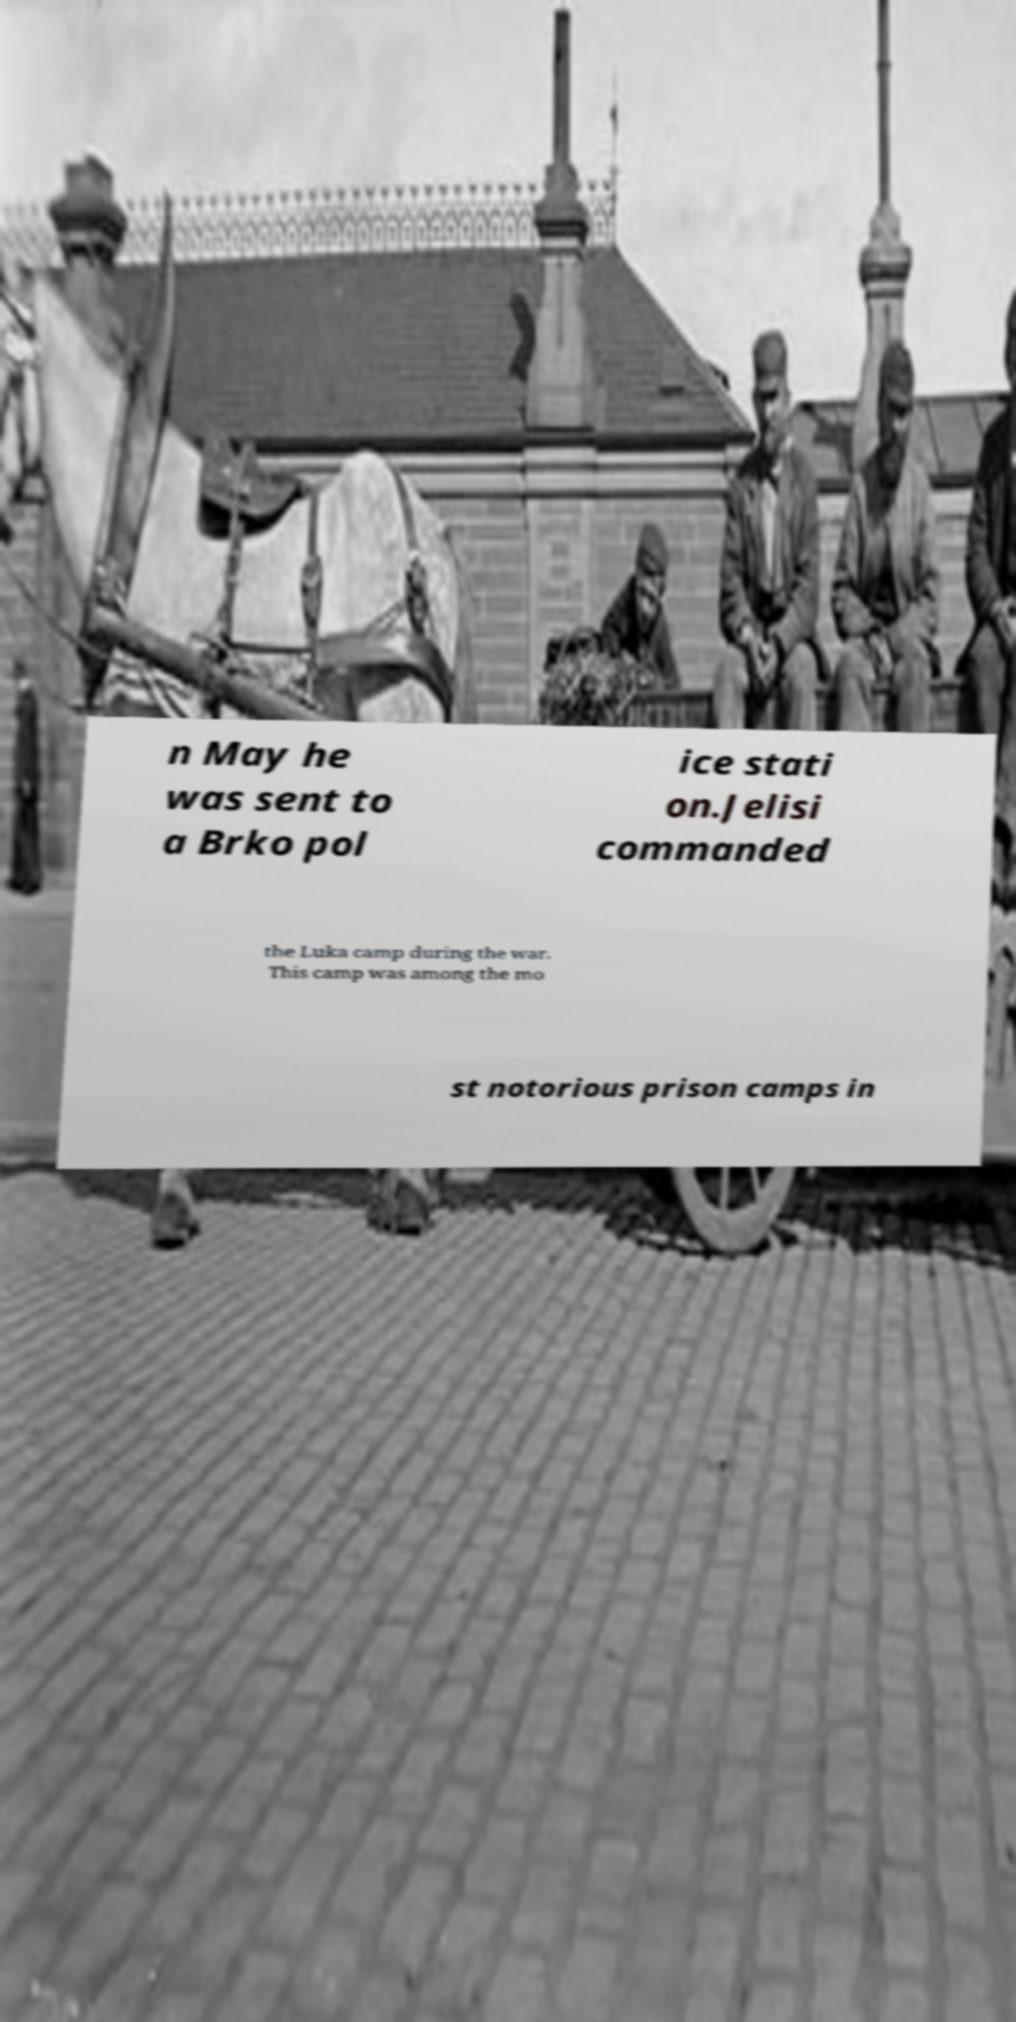Can you accurately transcribe the text from the provided image for me? n May he was sent to a Brko pol ice stati on.Jelisi commanded the Luka camp during the war. This camp was among the mo st notorious prison camps in 